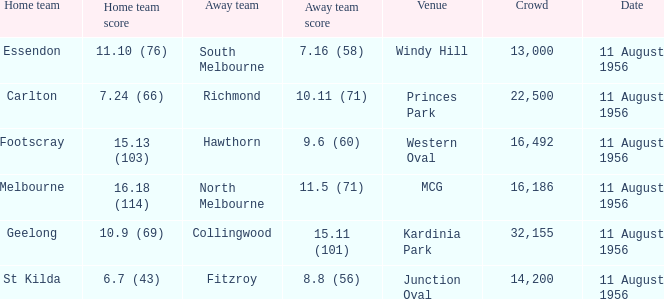What home team has a score of 16.18 (114)? Melbourne. 